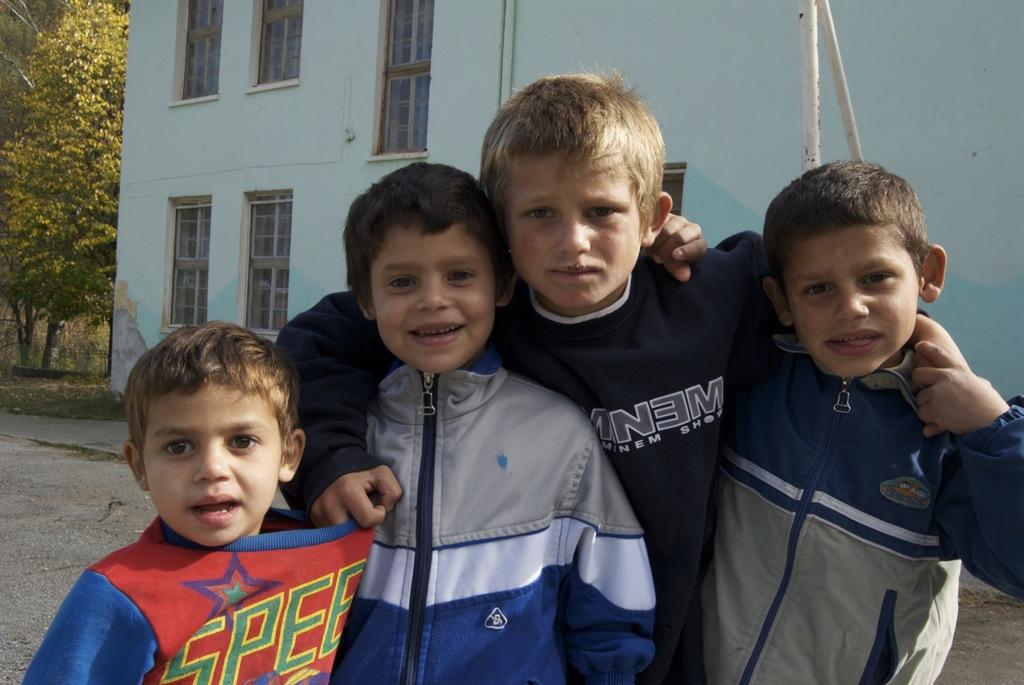Are all the jackets one brand name ?
Your response must be concise. No. What letter is backwards on the blue sweatshirt?
Provide a succinct answer. E. 